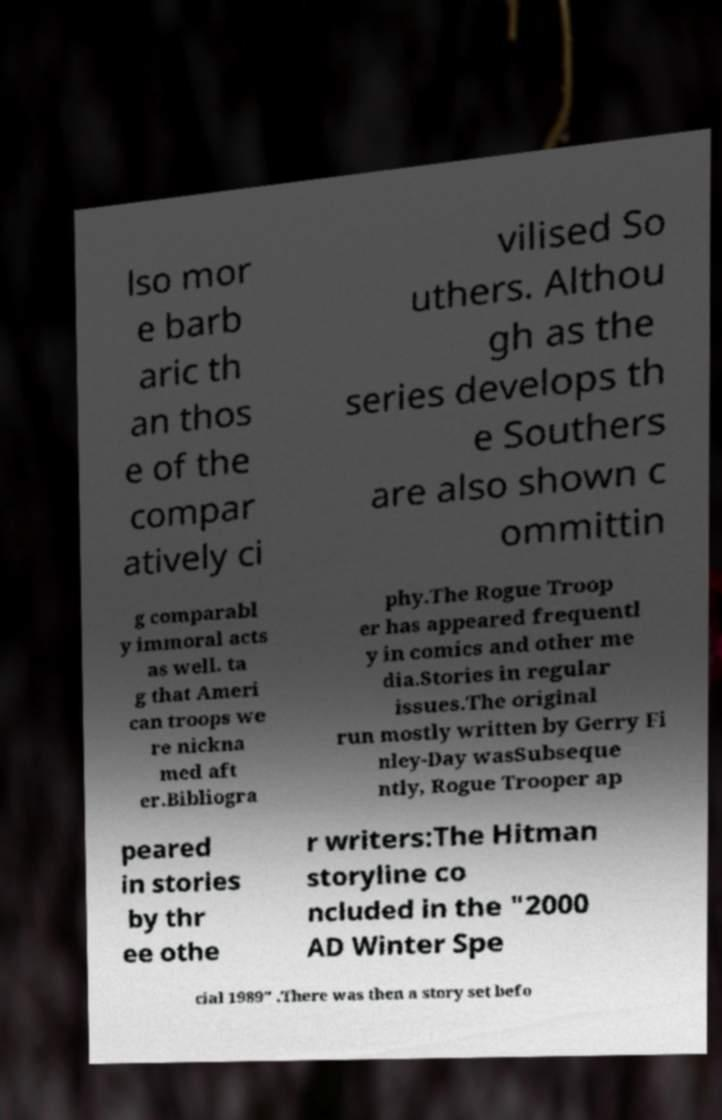Could you extract and type out the text from this image? lso mor e barb aric th an thos e of the compar atively ci vilised So uthers. Althou gh as the series develops th e Southers are also shown c ommittin g comparabl y immoral acts as well. ta g that Ameri can troops we re nickna med aft er.Bibliogra phy.The Rogue Troop er has appeared frequentl y in comics and other me dia.Stories in regular issues.The original run mostly written by Gerry Fi nley-Day wasSubseque ntly, Rogue Trooper ap peared in stories by thr ee othe r writers:The Hitman storyline co ncluded in the "2000 AD Winter Spe cial 1989" .There was then a story set befo 